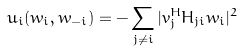Convert formula to latex. <formula><loc_0><loc_0><loc_500><loc_500>u _ { i } ( w _ { i } , w _ { - i } ) = - \sum _ { j \neq i } | v _ { j } ^ { H } H _ { j i } w _ { i } | ^ { 2 }</formula> 